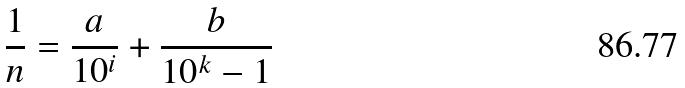Convert formula to latex. <formula><loc_0><loc_0><loc_500><loc_500>\frac { 1 } { n } = \frac { a } { 1 0 ^ { i } } + \frac { b } { 1 0 ^ { k } - 1 }</formula> 